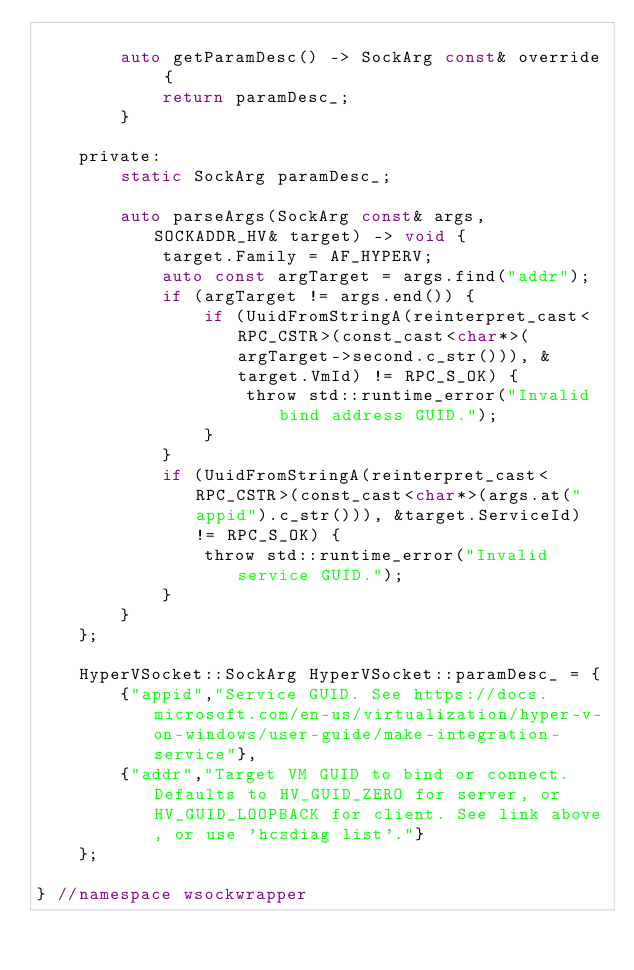<code> <loc_0><loc_0><loc_500><loc_500><_C_>
		auto getParamDesc() -> SockArg const& override {
			return paramDesc_;
		}

	private:
		static SockArg paramDesc_;

		auto parseArgs(SockArg const& args, SOCKADDR_HV& target) -> void {
			target.Family = AF_HYPERV;
			auto const argTarget = args.find("addr");
			if (argTarget != args.end()) {
				if (UuidFromStringA(reinterpret_cast<RPC_CSTR>(const_cast<char*>(argTarget->second.c_str())), &target.VmId) != RPC_S_OK) {
					throw std::runtime_error("Invalid bind address GUID.");
				}
			}
			if (UuidFromStringA(reinterpret_cast<RPC_CSTR>(const_cast<char*>(args.at("appid").c_str())), &target.ServiceId) != RPC_S_OK) {
				throw std::runtime_error("Invalid service GUID.");
			}
		}
	};

	HyperVSocket::SockArg HyperVSocket::paramDesc_ = {
		{"appid","Service GUID. See https://docs.microsoft.com/en-us/virtualization/hyper-v-on-windows/user-guide/make-integration-service"},
		{"addr","Target VM GUID to bind or connect. Defaults to HV_GUID_ZERO for server, or HV_GUID_LOOPBACK for client. See link above, or use 'hcsdiag list'."}
	};

} //namespace wsockwrapper</code> 